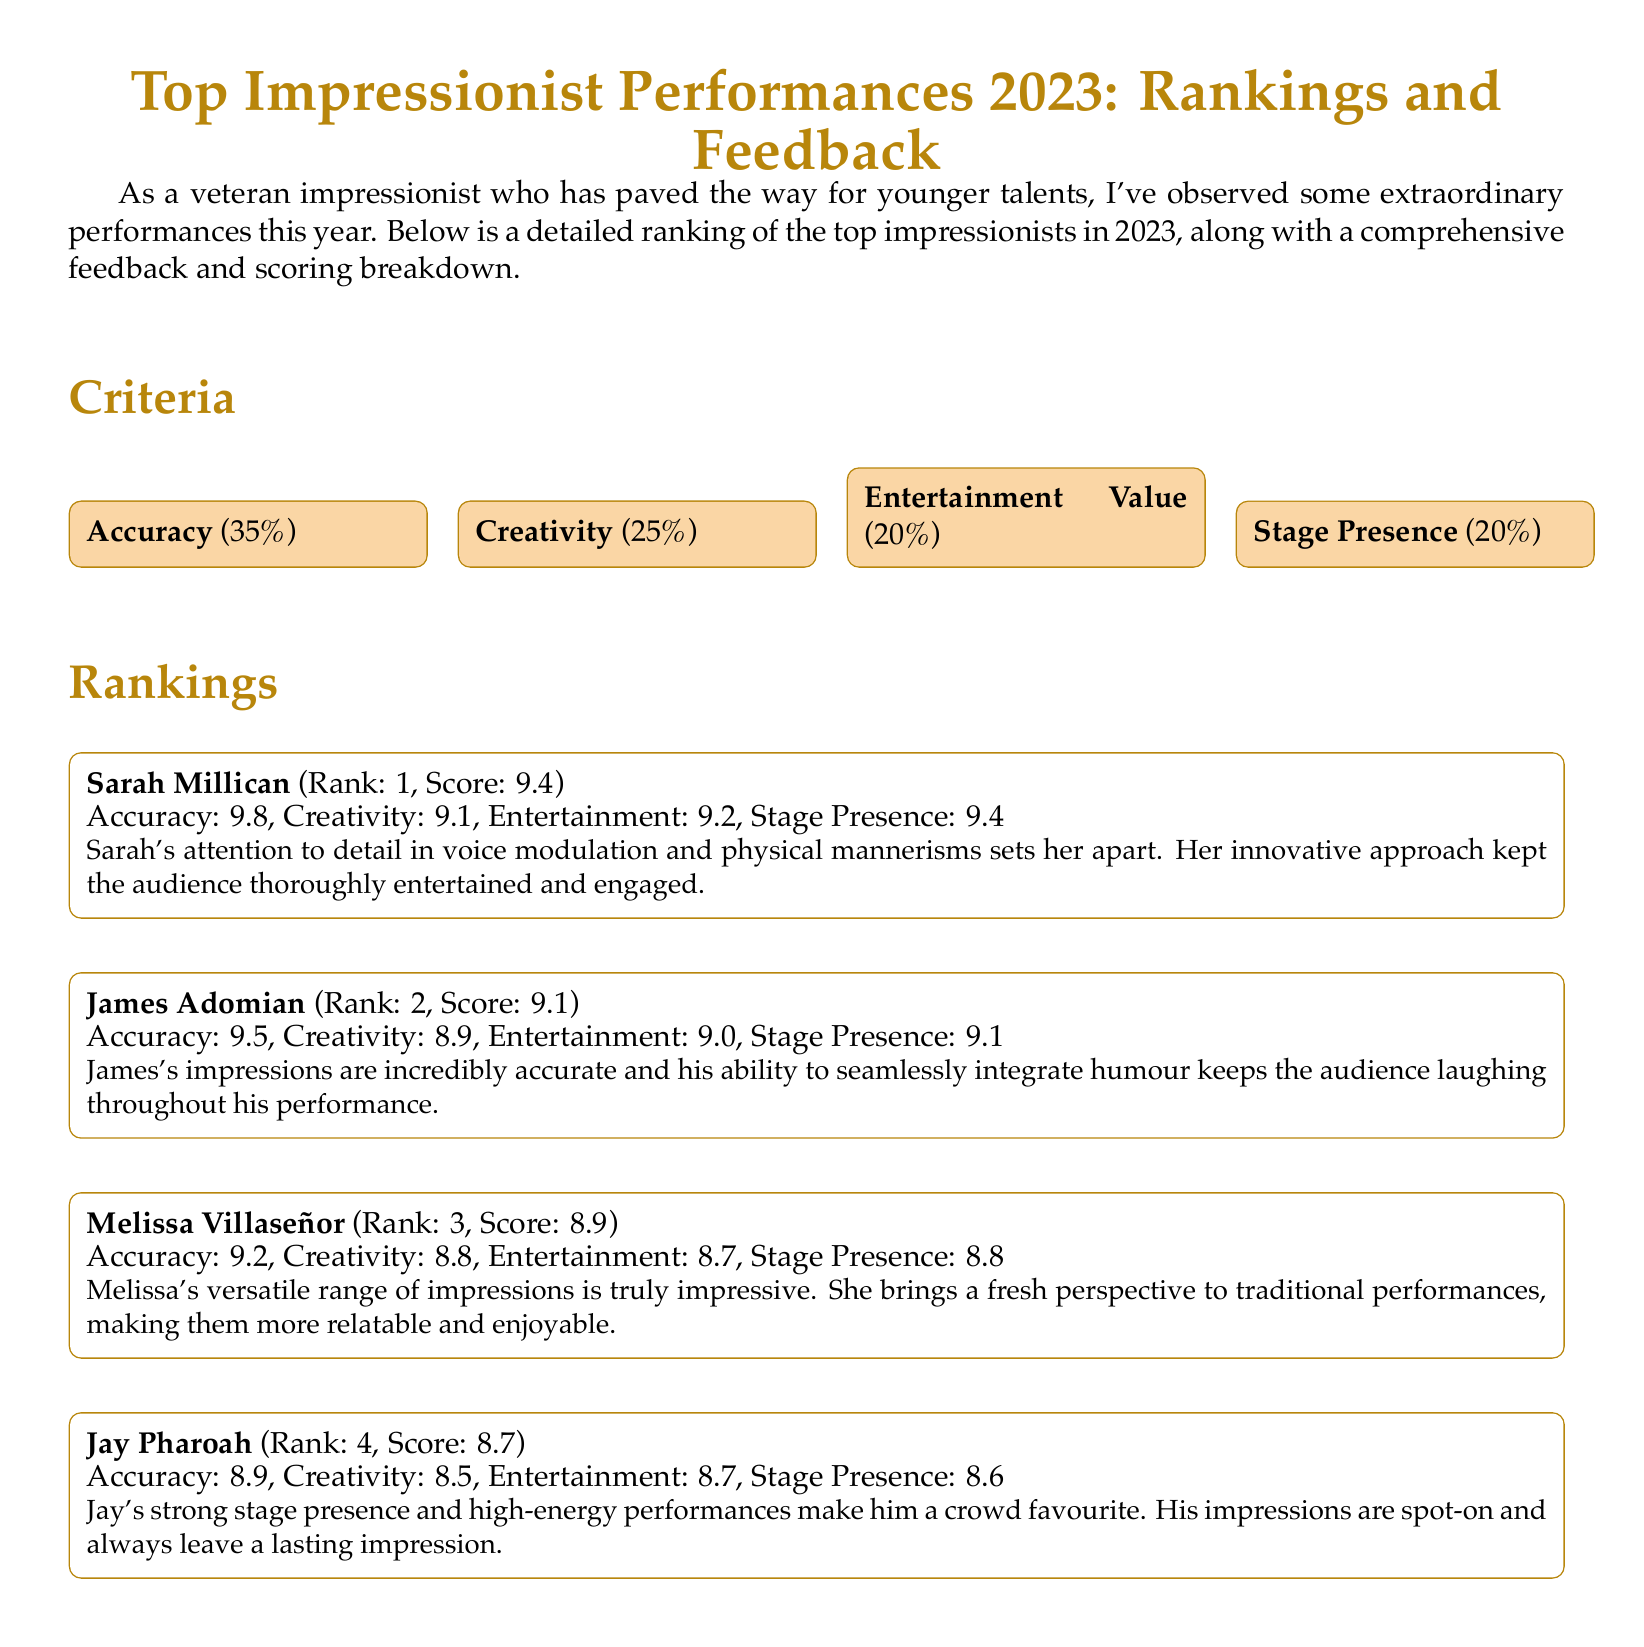What is the ranking of Sarah Millican? Sarah Millican is ranked first in the document.
Answer: 1 What percentage is allocated to the Accuracy criterion? The document specifies that Accuracy is 35% of the total score.
Answer: 35% Who scored the highest in Stage Presence? The highest score in Stage Presence is from Sarah Millican, who scored 9.4.
Answer: 9.4 What is the total score of James Adomian? The total score for James Adomian is listed as 9.1 in the document.
Answer: 9.1 Which performer has the lowest total score? The performer with the lowest total score in the rankings is Jay Pharoah.
Answer: Jay Pharoah What is the average score of Melissa Villaseñor in Entertainment Value? Melissa Villaseñor scored 8.7 in Entertainment Value, as mentioned in the scorecard.
Answer: 8.7 Which criteria has the least percentage? The least percentage criterion listed in the document is Entertainment Value.
Answer: Entertainment Value How many performers are included in the rankings? The document includes a total of four performers in the rankings.
Answer: Four 